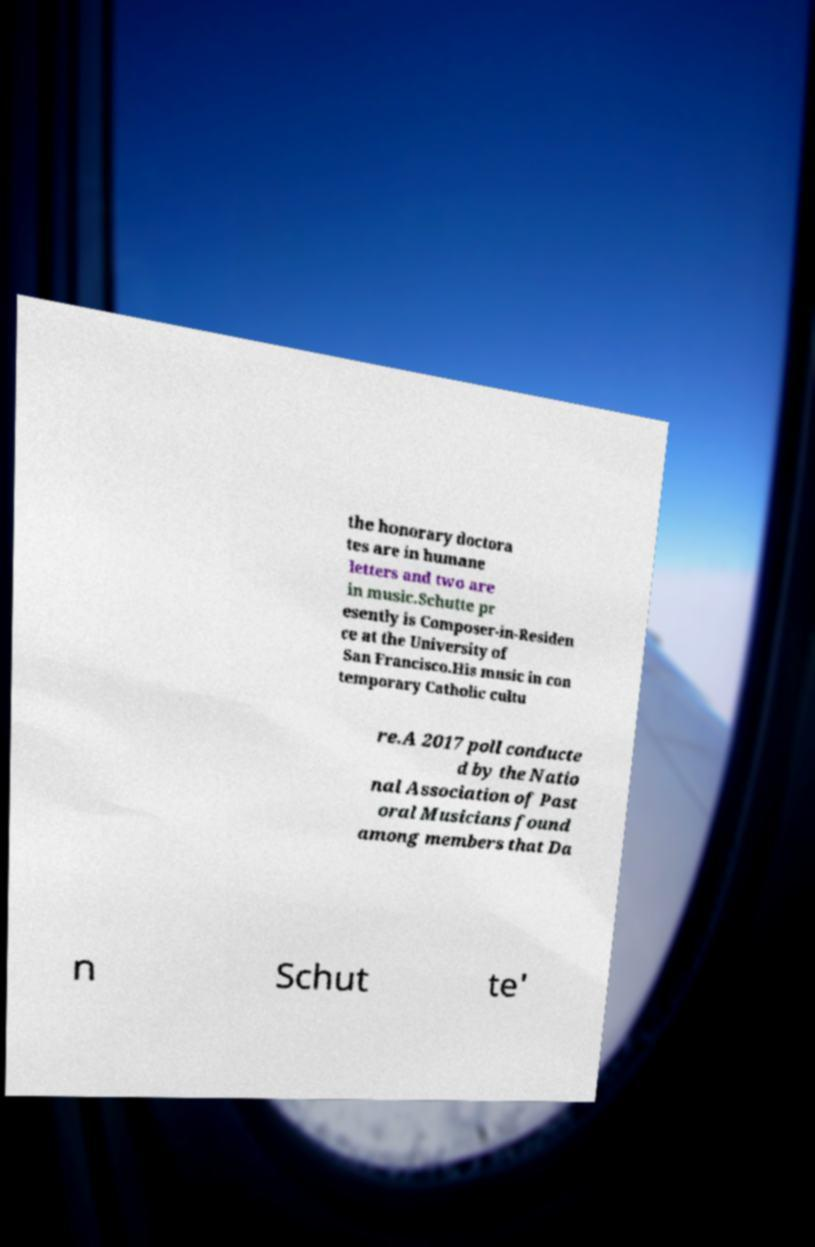Can you accurately transcribe the text from the provided image for me? the honorary doctora tes are in humane letters and two are in music.Schutte pr esently is Composer-in-Residen ce at the University of San Francisco.His music in con temporary Catholic cultu re.A 2017 poll conducte d by the Natio nal Association of Past oral Musicians found among members that Da n Schut te' 